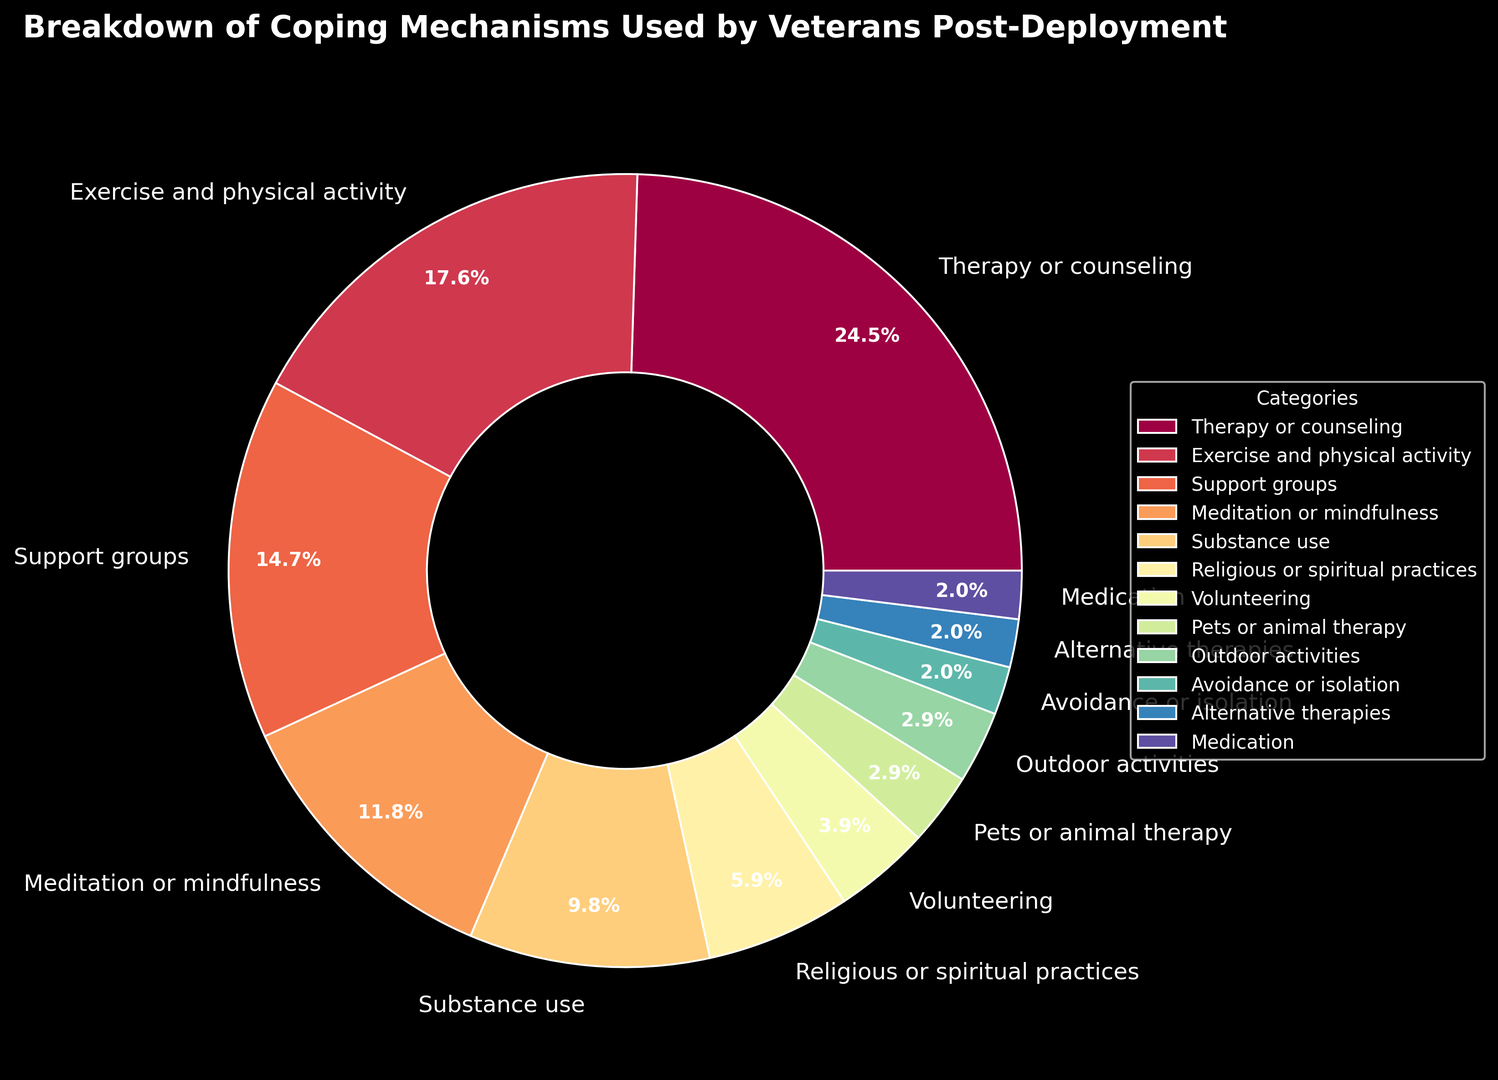What is the category with the highest percentage? To determine the highest percentage, look at the segment of the pie chart with the largest visual size or the highest percentage label. The "Therapy or counseling" segment is the largest, at 25%.
Answer: Therapy or counseling What is the combined percentage of Exercise and physical activity, and Support groups? To find the combined percentage, add the percentages of the two categories: Exercise and physical activity (18%) and Support groups (15%). Therefore, 18% + 15% = 33%.
Answer: 33% How many categories have a percentage of 5% or more? To determine this, count segments in the pie chart with percentage labels of 5% or more: Therapy or counseling (25%), Exercise and physical activity (18%), Support groups (15%), Meditation or mindfulness (12%), Substance use (10%), Religious or spiritual practices (6%). Hence, there are 6 categories.
Answer: 6 What is the visual difference between the wedges for Pets or animal therapy and Avoidance or isolation? Look at the sizes and labels of the wedges. Both Pets or animal therapy and Avoidance or isolation have relatively small visual segments, but Pets or animal therapy has a percentage label of 3%, whereas Avoidance or isolation has 2%.
Answer: Pets or animal therapy has a larger wedge than Avoidance or isolation Which categories have equal percentages? Identify wedges with the same percentage label. Medication (2%) and Alternative therapies (2%) have equal percentages.
Answer: Medication and Alternative therapies What is the average percentage of the top three coping mechanisms? First, identify the top three categories: Therapy or counseling (25%), Exercise and physical activity (18%), and Support groups (15%). Calculate the average: (25% + 18% + 15%) / 3 = 58 / 3 = 19.33%.
Answer: 19.33% How much more significant is the category with the highest percentage compared to the one with the lowest? The highest percentage is Therapy or counseling (25%), and the lowest is shared by Medication (2%) and Alternative therapies (2%). The difference is 25% - 2% = 23%.
Answer: 23% What is the total percentage represented by the categories of Substance use, Medication, and Alternative therapies? Add up the percentages of these categories: Substance use (10%), Medication (2%), and Alternative therapies (2%). Therefore, 10% + 2% + 2% = 14%.
Answer: 14% How many categories represent less than 5%? Count the segments with less than 5% each: Volunteering (4%), Pets or animal therapy (3%), Outdoor activities (3%), Avoidance or isolation (2%), Alternative therapies (2%), and Medication (2%). Thus, there are 6 categories.
Answer: 6 